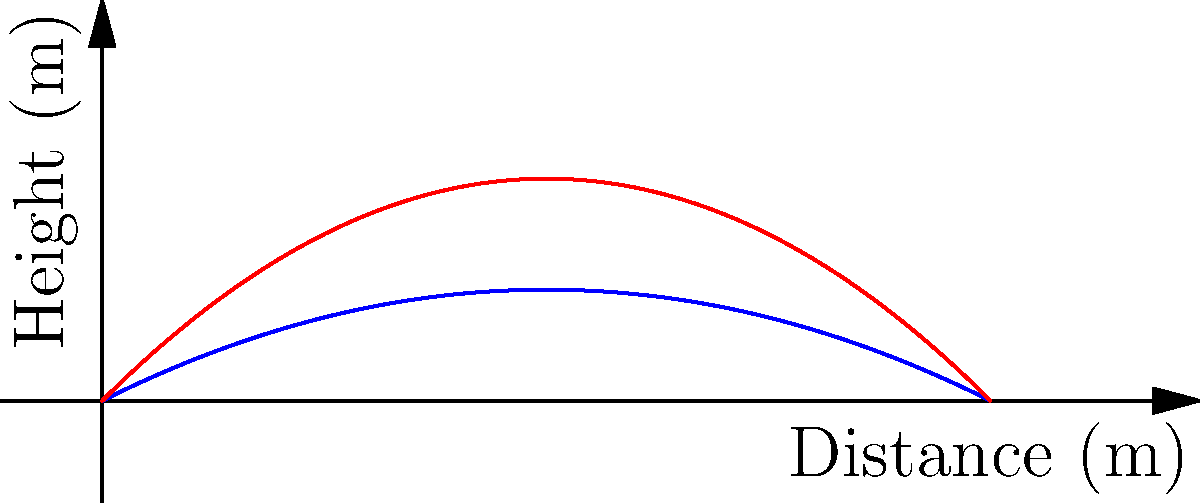A skilled hunter throws a harpoon at two different angles: 30° and 45°. The trajectories of the harpoon are shown in the graph, with the blue curve representing the 30° throw and the red curve representing the 45° throw. If the hunter aims to hit a seal at a distance of 8 meters, which angle should they choose to maximize the height of the harpoon at the target? To solve this problem, we need to compare the heights of the two trajectories at a distance of 8 meters:

1. For the 30° throw (blue curve):
   The function is approximately $f(x) = -0.05x^2 + 0.5x$
   At x = 8 meters: $f(8) = -0.05(8)^2 + 0.5(8) = -3.2 + 4 = 0.8$ meters

2. For the 45° throw (red curve):
   The function is approximately $g(x) = -0.1x^2 + x$
   At x = 8 meters: $g(8) = -0.1(8)^2 + 8 = -6.4 + 8 = 1.6$ meters

3. Compare the heights:
   30° throw: 0.8 meters
   45° throw: 1.6 meters

The 45° throw results in a greater height at the target distance of 8 meters.
Answer: 45° 